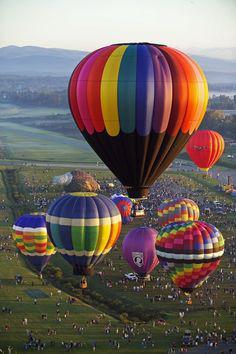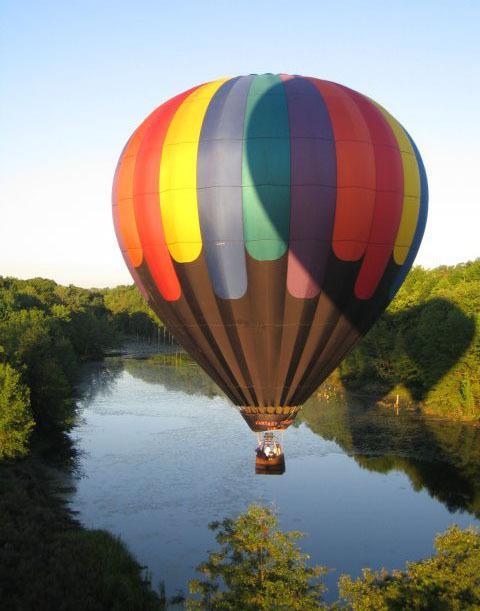The first image is the image on the left, the second image is the image on the right. Evaluate the accuracy of this statement regarding the images: "An image shows the interior of a balloon which is lying on the ground.". Is it true? Answer yes or no. No. The first image is the image on the left, the second image is the image on the right. Analyze the images presented: Is the assertion "One image shows a single balloon in midair with people in its basket and a view of the landscape under it including green areas." valid? Answer yes or no. Yes. 